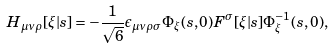Convert formula to latex. <formula><loc_0><loc_0><loc_500><loc_500>H _ { \mu \nu \rho } [ \xi | s ] = - \frac { 1 } { \sqrt { 6 } } \epsilon _ { \mu \nu \rho \sigma } \Phi _ { \xi } ( s , 0 ) F ^ { \sigma } [ \xi | s ] \Phi _ { \xi } ^ { - 1 } ( s , 0 ) ,</formula> 